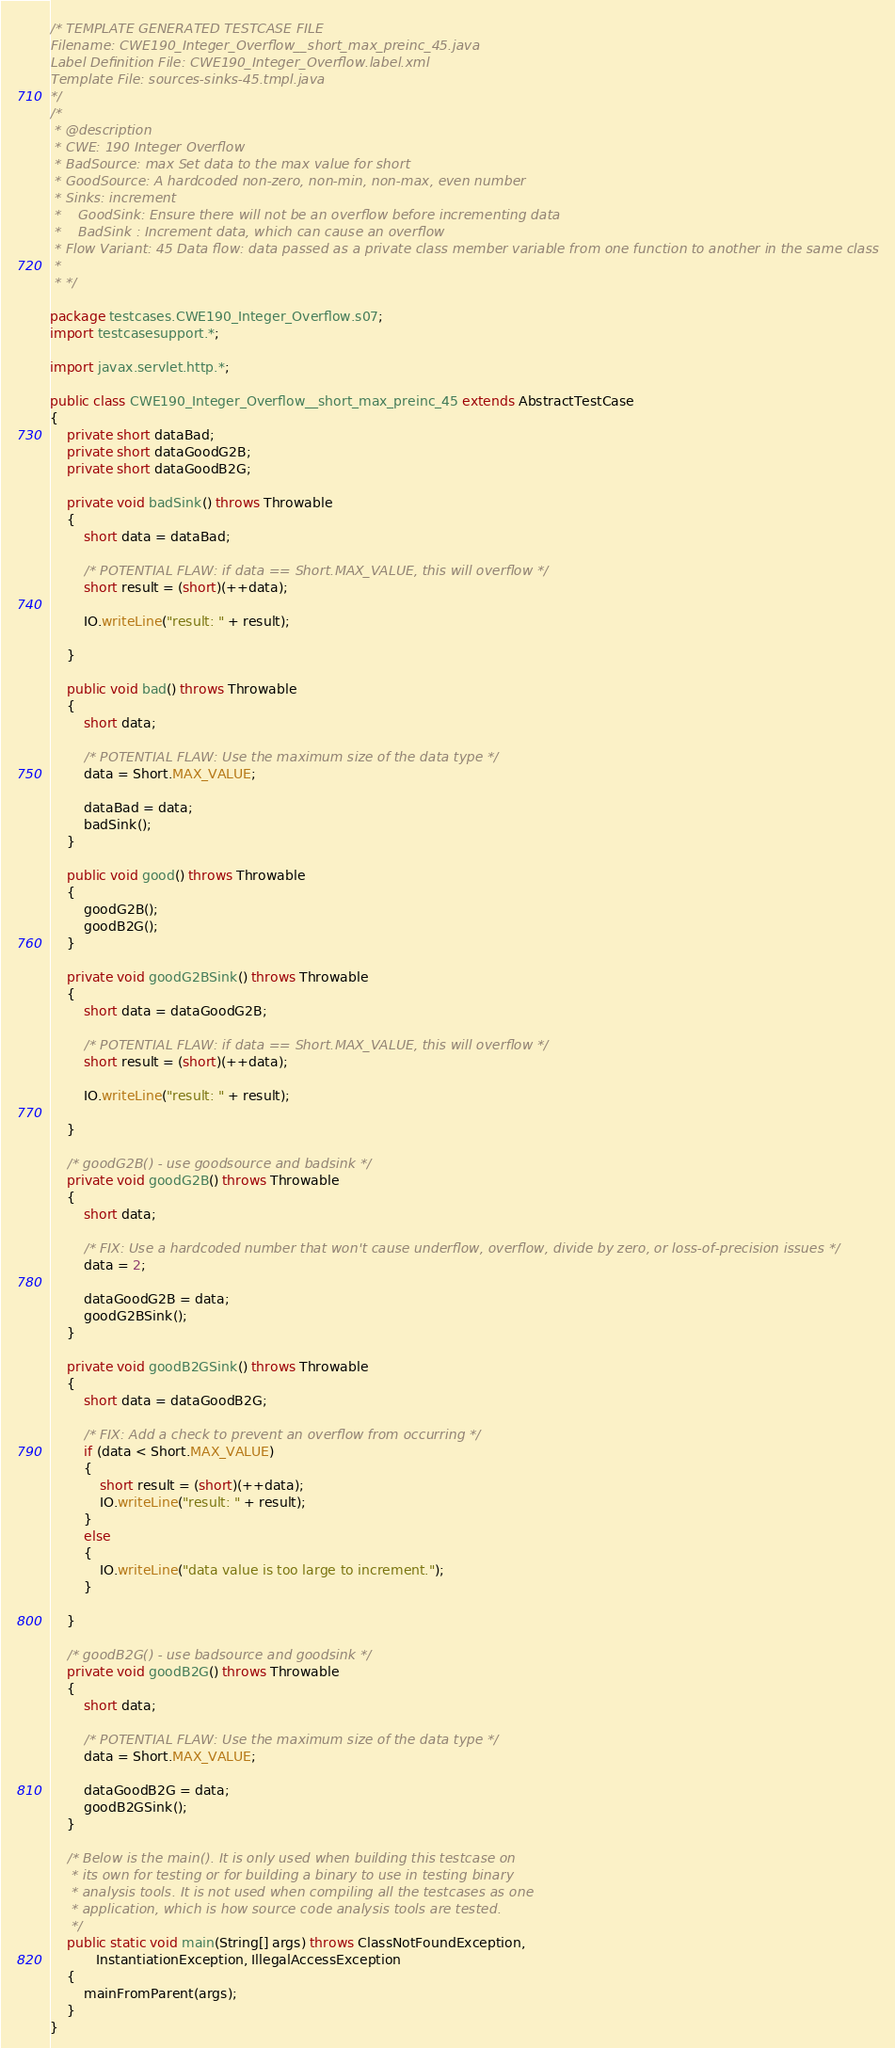<code> <loc_0><loc_0><loc_500><loc_500><_Java_>/* TEMPLATE GENERATED TESTCASE FILE
Filename: CWE190_Integer_Overflow__short_max_preinc_45.java
Label Definition File: CWE190_Integer_Overflow.label.xml
Template File: sources-sinks-45.tmpl.java
*/
/*
 * @description
 * CWE: 190 Integer Overflow
 * BadSource: max Set data to the max value for short
 * GoodSource: A hardcoded non-zero, non-min, non-max, even number
 * Sinks: increment
 *    GoodSink: Ensure there will not be an overflow before incrementing data
 *    BadSink : Increment data, which can cause an overflow
 * Flow Variant: 45 Data flow: data passed as a private class member variable from one function to another in the same class
 *
 * */

package testcases.CWE190_Integer_Overflow.s07;
import testcasesupport.*;

import javax.servlet.http.*;

public class CWE190_Integer_Overflow__short_max_preinc_45 extends AbstractTestCase
{
    private short dataBad;
    private short dataGoodG2B;
    private short dataGoodB2G;

    private void badSink() throws Throwable
    {
        short data = dataBad;

        /* POTENTIAL FLAW: if data == Short.MAX_VALUE, this will overflow */
        short result = (short)(++data);

        IO.writeLine("result: " + result);

    }

    public void bad() throws Throwable
    {
        short data;

        /* POTENTIAL FLAW: Use the maximum size of the data type */
        data = Short.MAX_VALUE;

        dataBad = data;
        badSink();
    }

    public void good() throws Throwable
    {
        goodG2B();
        goodB2G();
    }

    private void goodG2BSink() throws Throwable
    {
        short data = dataGoodG2B;

        /* POTENTIAL FLAW: if data == Short.MAX_VALUE, this will overflow */
        short result = (short)(++data);

        IO.writeLine("result: " + result);

    }

    /* goodG2B() - use goodsource and badsink */
    private void goodG2B() throws Throwable
    {
        short data;

        /* FIX: Use a hardcoded number that won't cause underflow, overflow, divide by zero, or loss-of-precision issues */
        data = 2;

        dataGoodG2B = data;
        goodG2BSink();
    }

    private void goodB2GSink() throws Throwable
    {
        short data = dataGoodB2G;

        /* FIX: Add a check to prevent an overflow from occurring */
        if (data < Short.MAX_VALUE)
        {
            short result = (short)(++data);
            IO.writeLine("result: " + result);
        }
        else
        {
            IO.writeLine("data value is too large to increment.");
        }

    }

    /* goodB2G() - use badsource and goodsink */
    private void goodB2G() throws Throwable
    {
        short data;

        /* POTENTIAL FLAW: Use the maximum size of the data type */
        data = Short.MAX_VALUE;

        dataGoodB2G = data;
        goodB2GSink();
    }

    /* Below is the main(). It is only used when building this testcase on
     * its own for testing or for building a binary to use in testing binary
     * analysis tools. It is not used when compiling all the testcases as one
     * application, which is how source code analysis tools are tested.
     */
    public static void main(String[] args) throws ClassNotFoundException,
           InstantiationException, IllegalAccessException
    {
        mainFromParent(args);
    }
}
</code> 